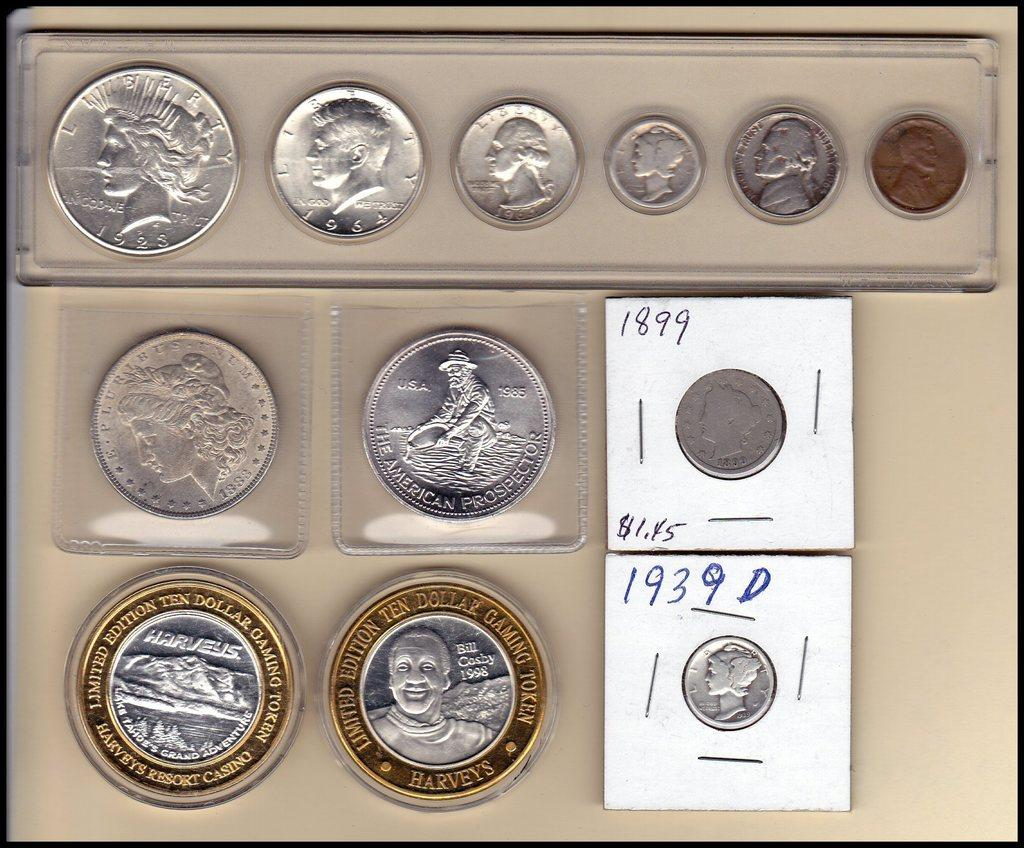<image>
Describe the image concisely. A collection of US coins in cases and a pair of Bill Cosby limited edition gaming tokens. 